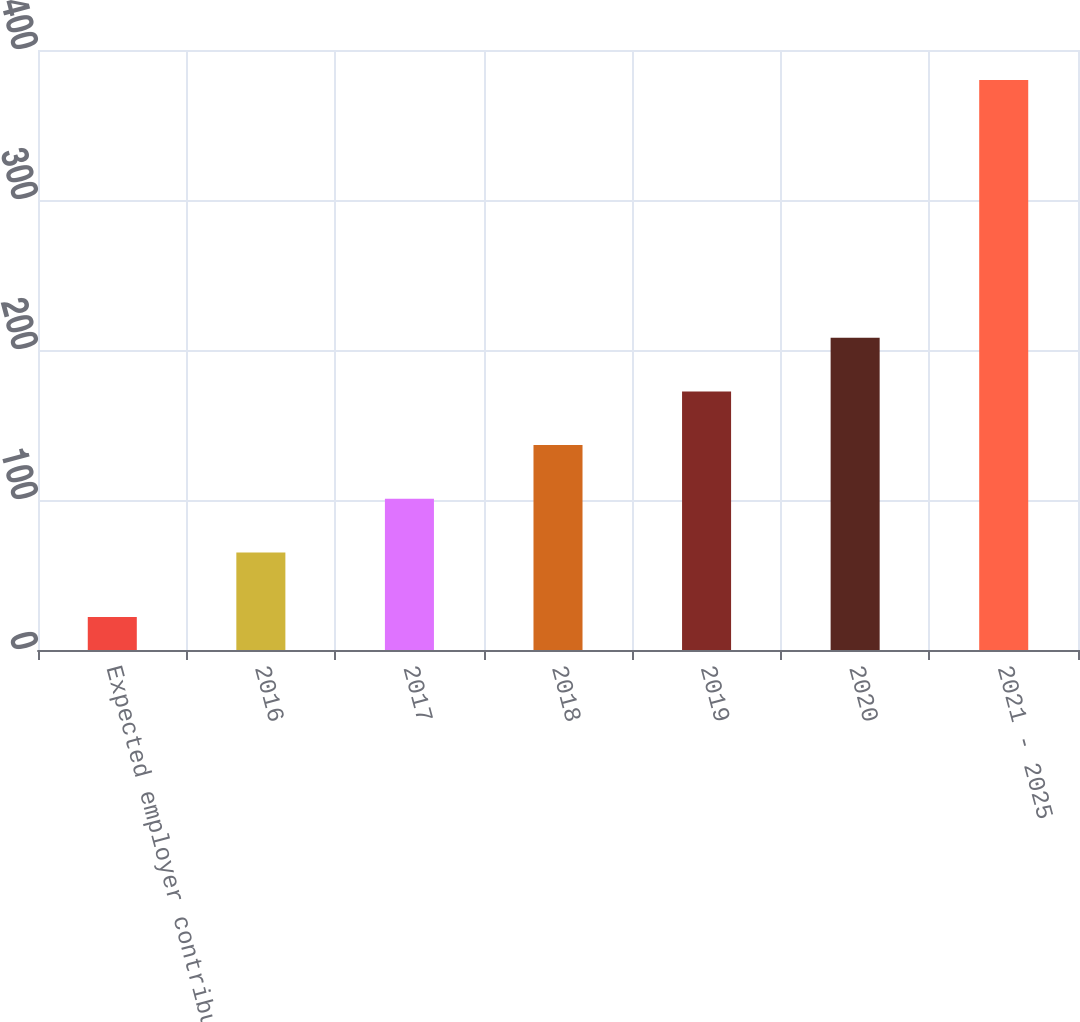Convert chart to OTSL. <chart><loc_0><loc_0><loc_500><loc_500><bar_chart><fcel>Expected employer contribution<fcel>2016<fcel>2017<fcel>2018<fcel>2019<fcel>2020<fcel>2021 - 2025<nl><fcel>22<fcel>65<fcel>100.8<fcel>136.6<fcel>172.4<fcel>208.2<fcel>380<nl></chart> 